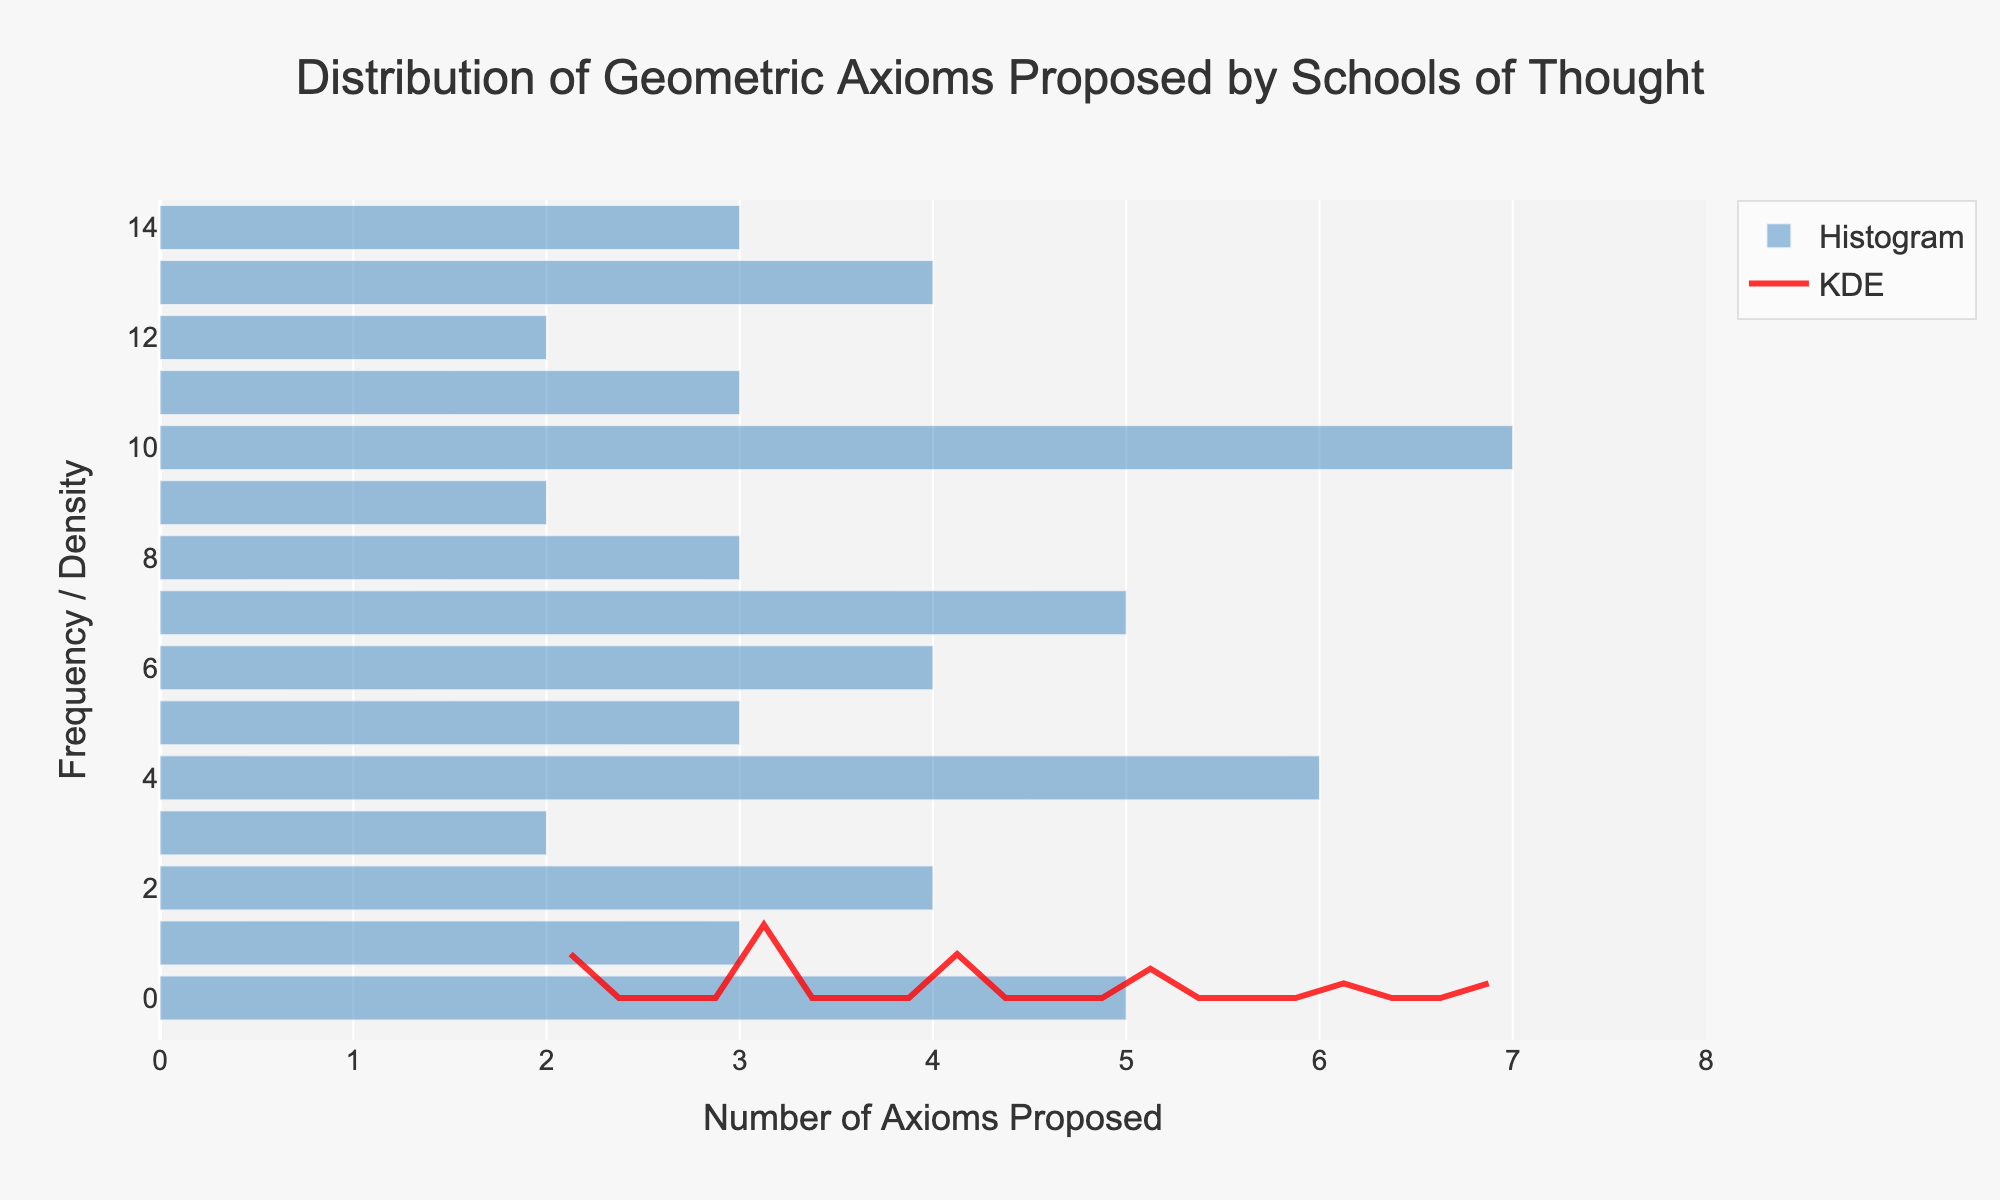What is the title of the plot? The title is located at the top of the plot and usually summarizes the main topic. Here, it reads "Distribution of Geometric Axioms Proposed by Schools of Thought".
Answer: Distribution of Geometric Axioms Proposed by Schools of Thought What are the x and y axes labels of the plot? The labels for the axes can be found adjacent to the respective axes, giving context to what the axes represent. The x-axis is labeled as "Number of Axioms Proposed" and the y-axis is labeled as "Frequency / Density".
Answer: Number of Axioms Proposed; Frequency / Density How many schools of thought have contributed a number of axioms within the range [2, 4]? This question requires counting the number of bars in the histogram that fall within the specified range. By observing the histogram, there are bars at positions 2, 3, and 4. Each position may have multiple schools contributing within this range.
Answer: 7 Which school has proposed the highest number of axioms? To find the highest number of axioms proposed, look for the bar corresponding to the maximum value on the x-axis, which is 7. The label for this bar indicates which school it belongs to. This is the "Riemannian" school.
Answer: Riemannian Compare the number of axioms proposed by Euclidean and Non-Euclidean schools. Which one proposed more? This involves looking at the histogram and locating the bars for "Euclidean" and "Non-Euclidean". "Euclidean" proposed 5 axioms, whereas "Non-Euclidean" proposed 3 axioms. Hence, Euclidean proposed more.
Answer: Euclidean What is the most frequent number of axioms proposed across all schools of thought? To identify this, look for the highest bar in the histogram, which represents the number most frequently proposed. Both 3 and 4 have high frequencies.
Answer: 3 and 4 What is the difference in frequency between the highest and lowest KDE values shown in the plot? Look at the KDE curve to find its peak (highest value) and its trough (lowest value). By calculating their difference, you'll understand the range of density in the data.
Answer: The exact difference would need a precise KDE value lookup, but visually it appears to be significant What does the KDE curve represent in the context of this plot? The KDE (Kernel Density Estimate) curve provides an estimate of the probability density function of the number of axioms proposed. It smooths out the data points to show the overall distribution pattern, making it easier to understand the density variations.
Answer: Distribution pattern and density estimation How is the opacity of the histogram bars described in the plot? To determine the opacity, observe the transparency effect on the bars in the histogram. According to the provided code, the opacity value is set to 0.7, which means the bars are 70% opaque, making them slightly transparent.
Answer: 70% or 0.7 What can be inferred about the contribution of synthetic geometries versus differential geometries in terms of axioms proposed? To compare these schools' contributions, look at the bars for "Synthetic" and "Differential". "Synthetic" geometries proposed 2 axioms, and "Differential" geometries proposed 5 axioms, indicating differential geometries have contributed more.
Answer: Differential geometries have contributed more 